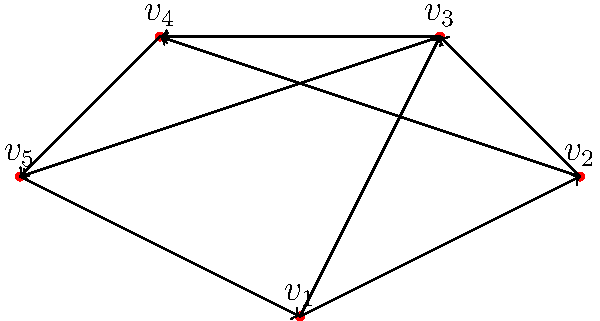In the directed graph representing foot traffic patterns in an urban space, what is the in-degree of vertex $v_3$, and how might this information be relevant to the placement of historical preservation sites or informational kiosks? To solve this problem, let's follow these steps:

1. Understand in-degree: The in-degree of a vertex is the number of edges pointing towards it.

2. Analyze vertex $v_3$:
   - There is an edge from $v_2$ to $v_3$
   - There is an edge from $v_1$ to $v_3$

3. Count the in-degree: There are 2 edges pointing towards $v_3$, so its in-degree is 2.

4. Relevance to historical preservation and urban planning:
   - A higher in-degree suggests that more pedestrians are moving towards this location from different directions.
   - This makes $v_3$ a potential hotspot for foot traffic, which could be ideal for:
     a) Placing informational kiosks about nearby historical sites
     b) Establishing a small preservation exhibit or marker
     c) Designing the space to accommodate higher pedestrian volumes
   - For a barista/architecture student, this information could be valuable in understanding how urban spaces interact with historical preservation efforts and how to integrate them effectively into the city's fabric.

5. Additional considerations:
   - The out-degree (edges leaving $v_3$) should also be considered for a complete traffic flow analysis.
   - Other factors like the overall connectivity of the graph and any cycles present could provide further insights into pedestrian movement patterns.
Answer: In-degree of $v_3$ is 2; ideal location for historical information kiosks due to high incoming foot traffic. 